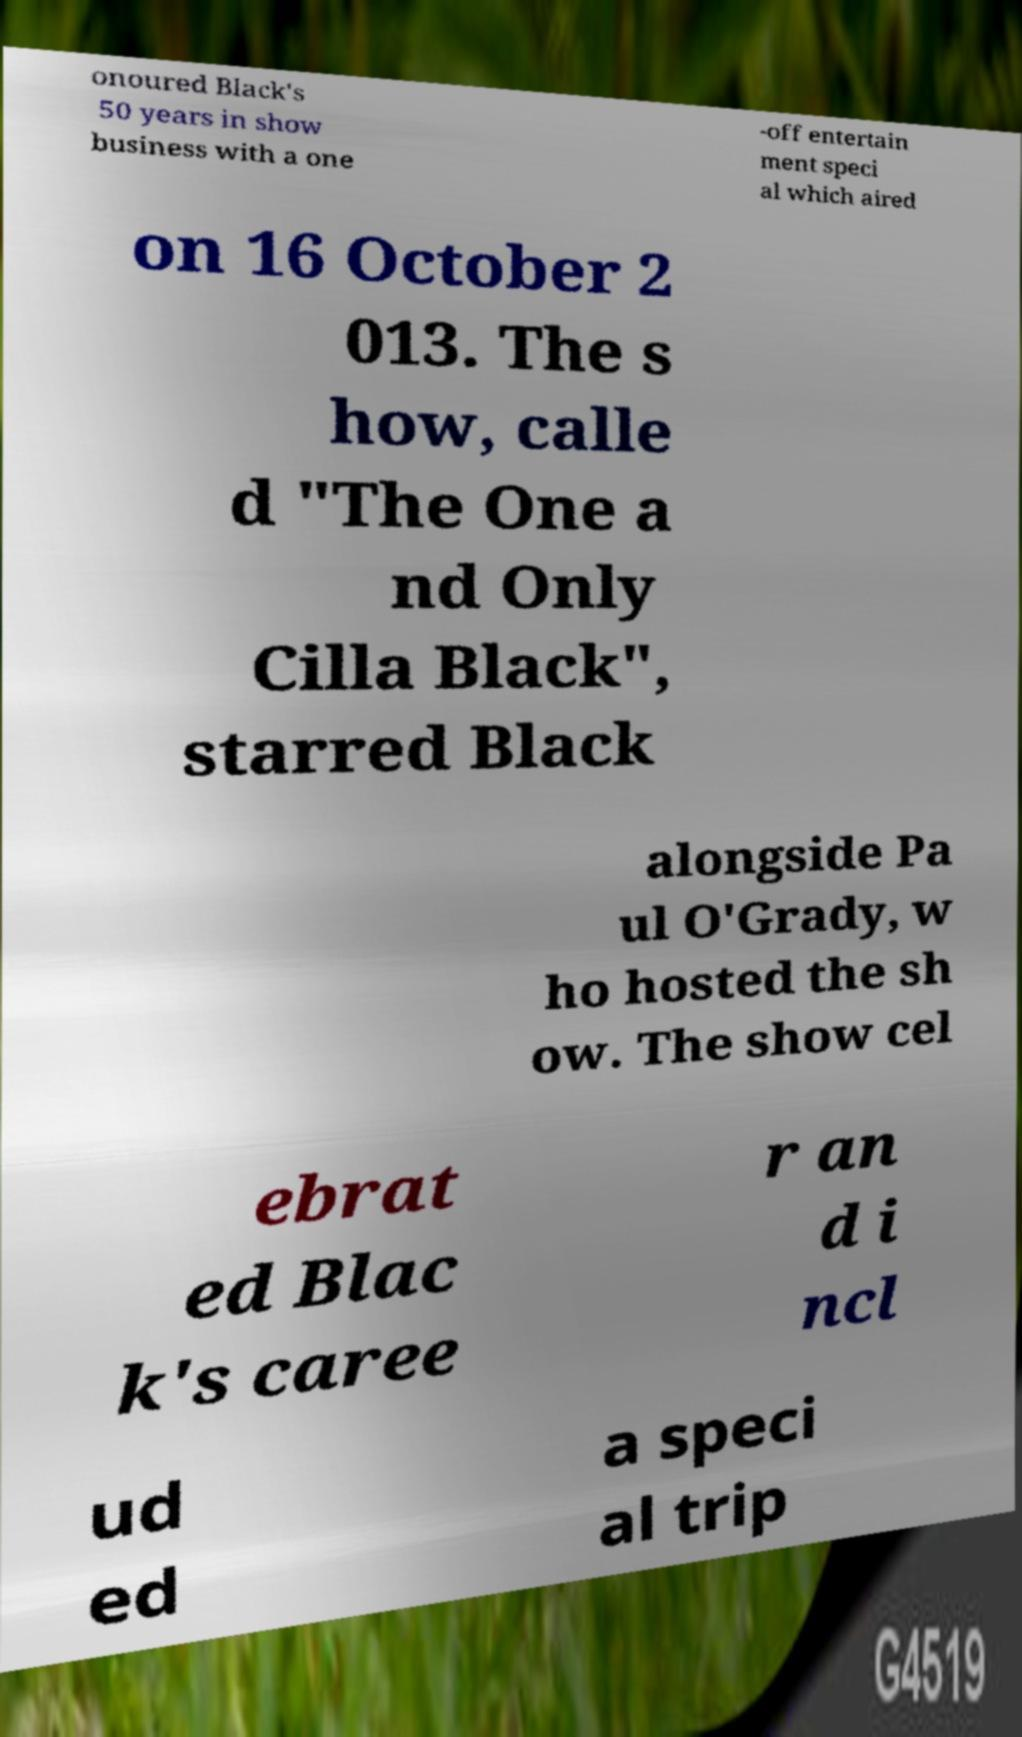Please identify and transcribe the text found in this image. onoured Black's 50 years in show business with a one -off entertain ment speci al which aired on 16 October 2 013. The s how, calle d "The One a nd Only Cilla Black", starred Black alongside Pa ul O'Grady, w ho hosted the sh ow. The show cel ebrat ed Blac k's caree r an d i ncl ud ed a speci al trip 